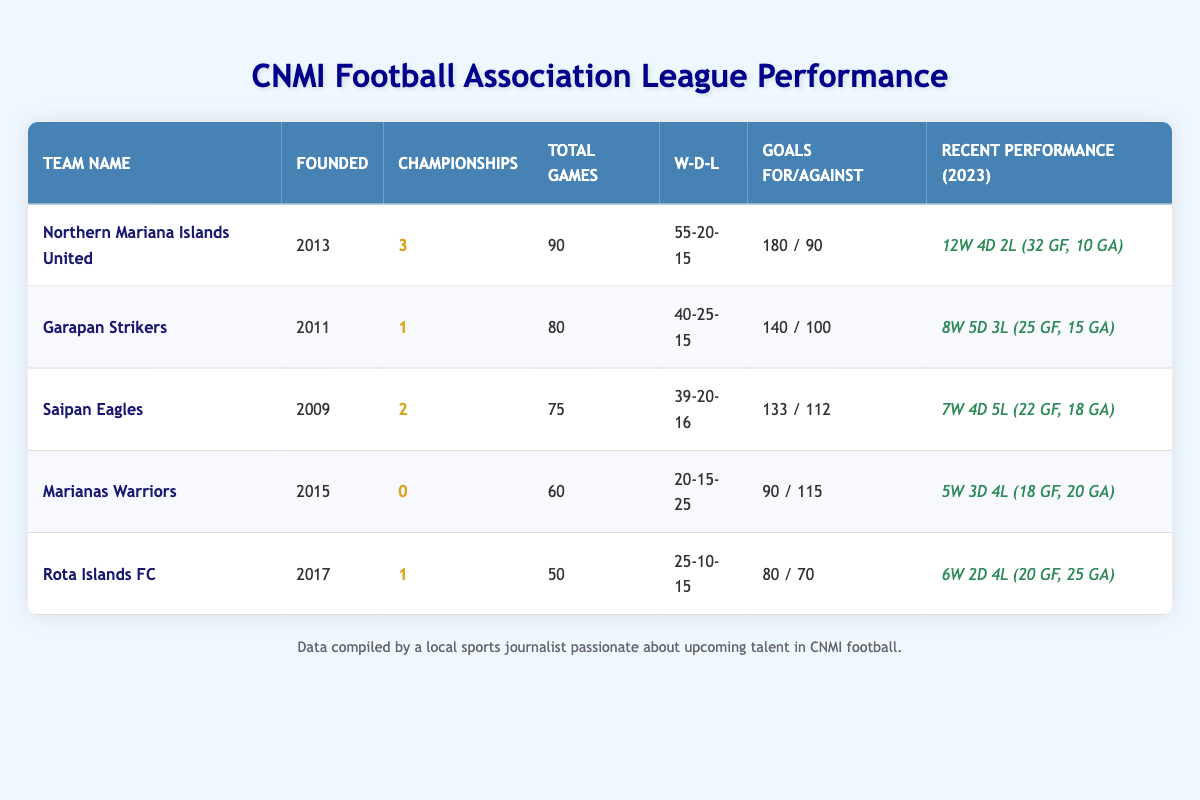What team has the most championships in the CNMI Football Association league? Looking at the table, Northern Mariana Islands United has won 3 championships, which is the highest among all teams listed.
Answer: Northern Mariana Islands United Which team has the least number of games played? The table shows that Rota Islands FC has played a total of 50 games, which is the least compared to other teams.
Answer: Rota Islands FC How many total matches has Garapan Strikers won or drawn? Garapan Strikers has won 40 matches and drawn 25 matches. Adding these together gives us 40 + 25 = 65.
Answer: 65 What is the goal difference for Saipan Eagles? Saipan Eagles scored 133 goals and conceded 112 goals. The goal difference is 133 - 112 = 21.
Answer: 21 Does Marianas Warriors have any championships? The table indicates that Marianas Warriors have won 0 championships, confirming that they have not won any.
Answer: Yes, 0 championships Which team had the best recent performance in terms of wins during the 2023 season? By checking the recent performance data, Northern Mariana Islands United had 12 wins in 2023, which is higher than the wins recorded by any other team.
Answer: Northern Mariana Islands United What is the average number of goals scored per game by Rota Islands FC? Rota Islands FC scored 80 goals in 50 games. The average goals per game is calculated by dividing the total goals by total games: 80 / 50 = 1.6.
Answer: 1.6 How many matches in total did Marianas Warriors win? According to the data, Marianas Warriors won 20 matches, which is explicitly stated in their performance data.
Answer: 20 Which team scored the most goals over the course of their history in the league? Northern Mariana Islands United scored 180 goals, which is the highest in the table, surpassing all others.
Answer: Northern Mariana Islands United What is the overall win rate for Saipan Eagles based on their historical data? Saipan Eagles won 39 out of 75 total matches. The win rate is calculated as (39/75)*100 = 52%.
Answer: 52% 